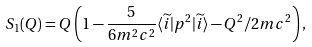Convert formula to latex. <formula><loc_0><loc_0><loc_500><loc_500>S _ { 1 } ( Q ) = Q \left ( 1 - \frac { 5 } { 6 m ^ { 2 } c ^ { 2 } } \langle \widetilde { i } | p ^ { 2 } | \widetilde { i } \rangle - Q ^ { 2 } / 2 m c ^ { 2 } \right ) ,</formula> 